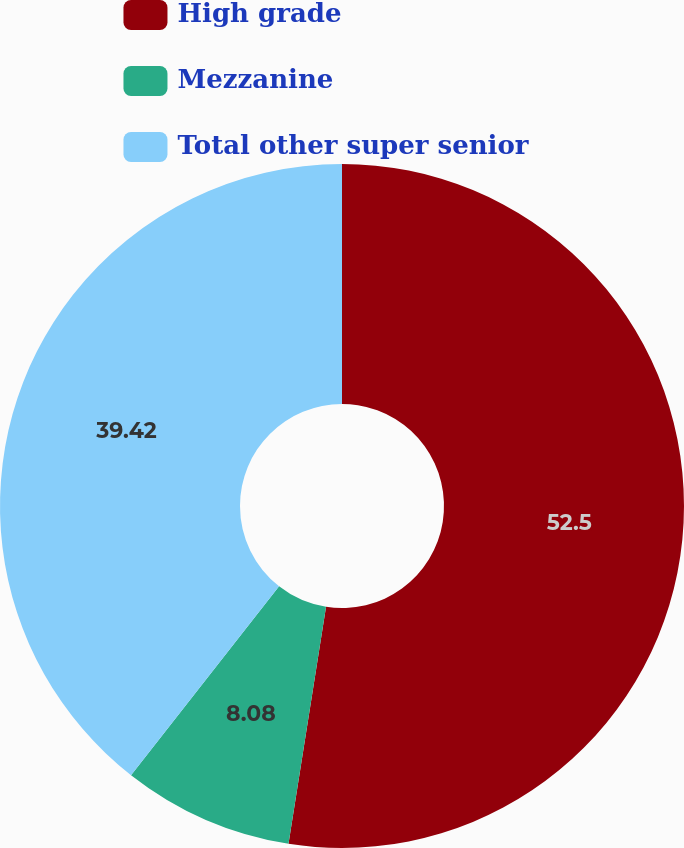<chart> <loc_0><loc_0><loc_500><loc_500><pie_chart><fcel>High grade<fcel>Mezzanine<fcel>Total other super senior<nl><fcel>52.5%<fcel>8.08%<fcel>39.42%<nl></chart> 